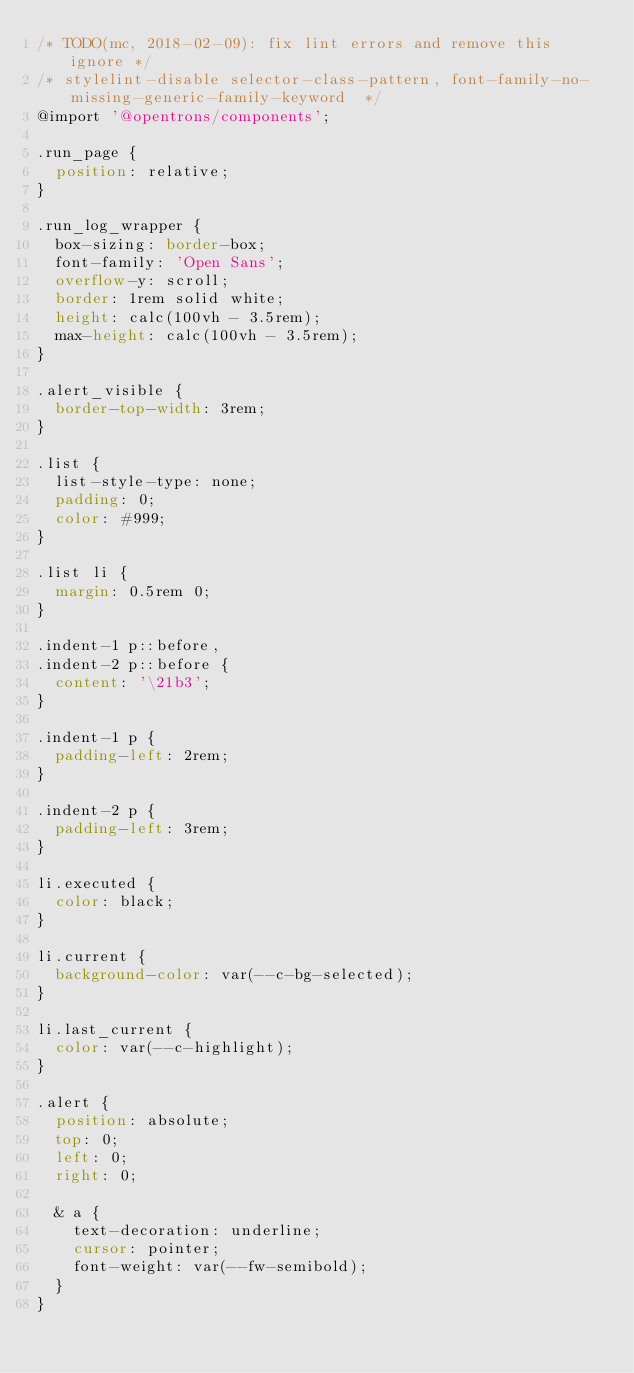<code> <loc_0><loc_0><loc_500><loc_500><_CSS_>/* TODO(mc, 2018-02-09): fix lint errors and remove this ignore */
/* stylelint-disable selector-class-pattern, font-family-no-missing-generic-family-keyword  */
@import '@opentrons/components';

.run_page {
  position: relative;
}

.run_log_wrapper {
  box-sizing: border-box;
  font-family: 'Open Sans';
  overflow-y: scroll;
  border: 1rem solid white;
  height: calc(100vh - 3.5rem);
  max-height: calc(100vh - 3.5rem);
}

.alert_visible {
  border-top-width: 3rem;
}

.list {
  list-style-type: none;
  padding: 0;
  color: #999;
}

.list li {
  margin: 0.5rem 0;
}

.indent-1 p::before,
.indent-2 p::before {
  content: '\21b3';
}

.indent-1 p {
  padding-left: 2rem;
}

.indent-2 p {
  padding-left: 3rem;
}

li.executed {
  color: black;
}

li.current {
  background-color: var(--c-bg-selected);
}

li.last_current {
  color: var(--c-highlight);
}

.alert {
  position: absolute;
  top: 0;
  left: 0;
  right: 0;

  & a {
    text-decoration: underline;
    cursor: pointer;
    font-weight: var(--fw-semibold);
  }
}
</code> 